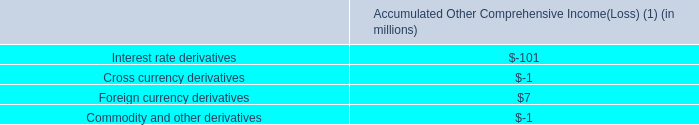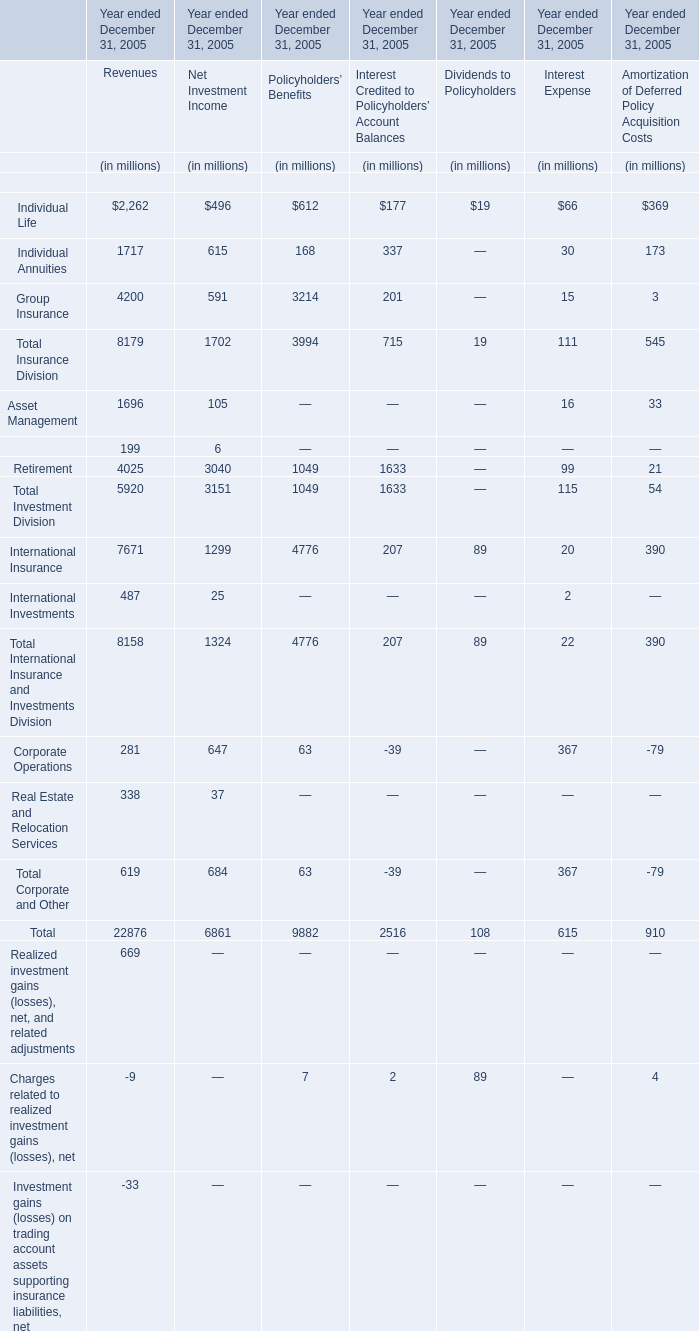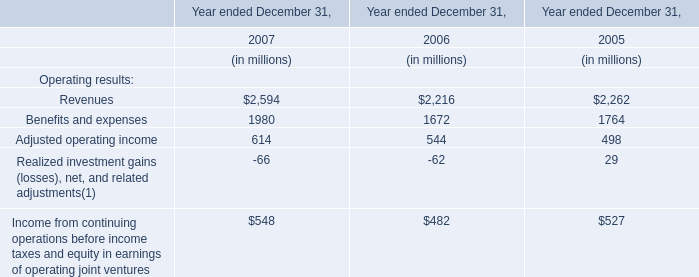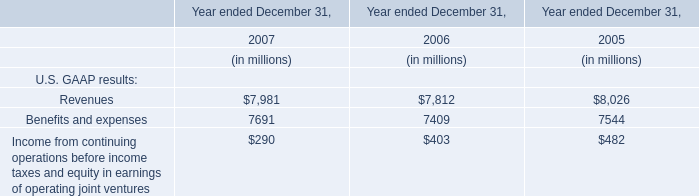In the section with lowest amount of Individual Life , what's the amount of Individual Life and Total Insurance Division? (in million) 
Computations: (19 + 19)
Answer: 38.0. 